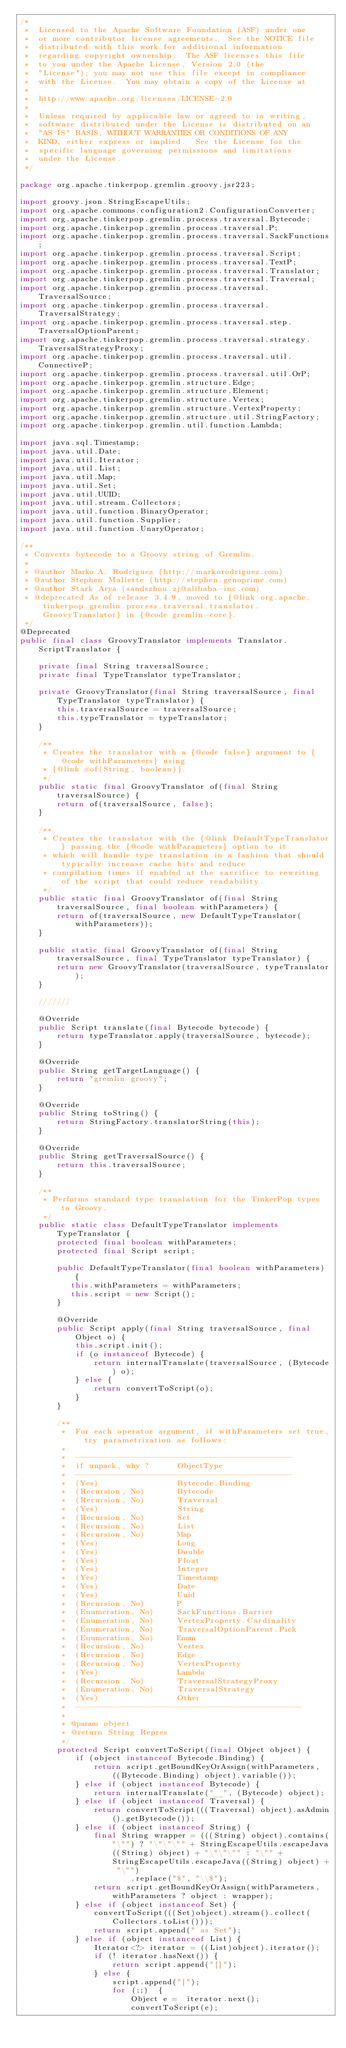Convert code to text. <code><loc_0><loc_0><loc_500><loc_500><_Java_>/*
 *  Licensed to the Apache Software Foundation (ASF) under one
 *  or more contributor license agreements.  See the NOTICE file
 *  distributed with this work for additional information
 *  regarding copyright ownership.  The ASF licenses this file
 *  to you under the Apache License, Version 2.0 (the
 *  "License"); you may not use this file except in compliance
 *  with the License.  You may obtain a copy of the License at
 *
 *  http://www.apache.org/licenses/LICENSE-2.0
 *
 *  Unless required by applicable law or agreed to in writing,
 *  software distributed under the License is distributed on an
 *  "AS IS" BASIS, WITHOUT WARRANTIES OR CONDITIONS OF ANY
 *  KIND, either express or implied.  See the License for the
 *  specific language governing permissions and limitations
 *  under the License.
 */

package org.apache.tinkerpop.gremlin.groovy.jsr223;

import groovy.json.StringEscapeUtils;
import org.apache.commons.configuration2.ConfigurationConverter;
import org.apache.tinkerpop.gremlin.process.traversal.Bytecode;
import org.apache.tinkerpop.gremlin.process.traversal.P;
import org.apache.tinkerpop.gremlin.process.traversal.SackFunctions;
import org.apache.tinkerpop.gremlin.process.traversal.Script;
import org.apache.tinkerpop.gremlin.process.traversal.TextP;
import org.apache.tinkerpop.gremlin.process.traversal.Translator;
import org.apache.tinkerpop.gremlin.process.traversal.Traversal;
import org.apache.tinkerpop.gremlin.process.traversal.TraversalSource;
import org.apache.tinkerpop.gremlin.process.traversal.TraversalStrategy;
import org.apache.tinkerpop.gremlin.process.traversal.step.TraversalOptionParent;
import org.apache.tinkerpop.gremlin.process.traversal.strategy.TraversalStrategyProxy;
import org.apache.tinkerpop.gremlin.process.traversal.util.ConnectiveP;
import org.apache.tinkerpop.gremlin.process.traversal.util.OrP;
import org.apache.tinkerpop.gremlin.structure.Edge;
import org.apache.tinkerpop.gremlin.structure.Element;
import org.apache.tinkerpop.gremlin.structure.Vertex;
import org.apache.tinkerpop.gremlin.structure.VertexProperty;
import org.apache.tinkerpop.gremlin.structure.util.StringFactory;
import org.apache.tinkerpop.gremlin.util.function.Lambda;

import java.sql.Timestamp;
import java.util.Date;
import java.util.Iterator;
import java.util.List;
import java.util.Map;
import java.util.Set;
import java.util.UUID;
import java.util.stream.Collectors;
import java.util.function.BinaryOperator;
import java.util.function.Supplier;
import java.util.function.UnaryOperator;

/**
 * Converts bytecode to a Groovy string of Gremlin.
 *
 * @author Marko A. Rodriguez (http://markorodriguez.com)
 * @author Stephen Mallette (http://stephen.genoprime.com)
 * @author Stark Arya (sandszhou.zj@alibaba-inc.com)
 * @deprecated As of release 3.4.9, moved to {@link org.apache.tinkerpop.gremlin.process.traversal.translator.GroovyTranslator} in {@code gremlin-core}.
 */
@Deprecated
public final class GroovyTranslator implements Translator.ScriptTranslator {

    private final String traversalSource;
    private final TypeTranslator typeTranslator;

    private GroovyTranslator(final String traversalSource, final TypeTranslator typeTranslator) {
        this.traversalSource = traversalSource;
        this.typeTranslator = typeTranslator;
    }

    /**
     * Creates the translator with a {@code false} argument to {@code withParameters} using
     * {@link #of(String, boolean)}.
     */
    public static final GroovyTranslator of(final String traversalSource) {
        return of(traversalSource, false);
    }

    /**
     * Creates the translator with the {@link DefaultTypeTranslator} passing the {@code withParameters} option to it
     * which will handle type translation in a fashion that should typically increase cache hits and reduce
     * compilation times if enabled at the sacrifice to rewriting of the script that could reduce readability.
     */
    public static final GroovyTranslator of(final String traversalSource, final boolean withParameters) {
        return of(traversalSource, new DefaultTypeTranslator(withParameters));
    }

    public static final GroovyTranslator of(final String traversalSource, final TypeTranslator typeTranslator) {
        return new GroovyTranslator(traversalSource, typeTranslator);
    }

    ///////

    @Override
    public Script translate(final Bytecode bytecode) {
        return typeTranslator.apply(traversalSource, bytecode);
    }

    @Override
    public String getTargetLanguage() {
        return "gremlin-groovy";
    }

    @Override
    public String toString() {
        return StringFactory.translatorString(this);
    }

    @Override
    public String getTraversalSource() {
        return this.traversalSource;
    }

    /**
     * Performs standard type translation for the TinkerPop types to Groovy.
     */
    public static class DefaultTypeTranslator implements TypeTranslator {
        protected final boolean withParameters;
        protected final Script script;

        public DefaultTypeTranslator(final boolean withParameters) {
           this.withParameters = withParameters;
           this.script = new Script();
        }

        @Override
        public Script apply(final String traversalSource, final Object o) {
            this.script.init();
            if (o instanceof Bytecode) {
                return internalTranslate(traversalSource, (Bytecode) o);
            } else {
                return convertToScript(o);
            }
        }

        /**
         *  For each operator argument, if withParameters set true, try parametrization as follows:
         *
         *  -----------------------------------------------
         *  if unpack, why ?      ObjectType
         *  -----------------------------------------------
         *  (Yes)                 Bytecode.Binding
         *  (Recursion, No)       Bytecode
         *  (Recursion, No)       Traversal
         *  (Yes)                 String
         *  (Recursion, No)       Set
         *  (Recursion, No)       List
         *  (Recursion, No)       Map
         *  (Yes)                 Long
         *  (Yes)                 Double
         *  (Yes)                 Float
         *  (Yes)                 Integer
         *  (Yes)                 Timestamp
         *  (Yes)                 Date
         *  (Yes)                 Uuid
         *  (Recursion, No)       P
         *  (Enumeration, No)     SackFunctions.Barrier
         *  (Enumeration, No)     VertexProperty.Cardinality
         *  (Enumeration, No)     TraversalOptionParent.Pick
         *  (Enumeration, No)     Enum
         *  (Recursion, No)       Vertex
         *  (Recursion, No)       Edge
         *  (Recursion, No)       VertexProperty
         *  (Yes)                 Lambda
         *  (Recursion, No)       TraversalStrategyProxy
         *  (Enumeration, No)     TraversalStrategy
         *  (Yes)                 Other
         *  -------------------------------------------------
         *
         * @param object
         * @return String Repres
         */
        protected Script convertToScript(final Object object) {
            if (object instanceof Bytecode.Binding) {
                return script.getBoundKeyOrAssign(withParameters, ((Bytecode.Binding) object).variable());
            } else if (object instanceof Bytecode) {
                return internalTranslate("__", (Bytecode) object);
            } else if (object instanceof Traversal) {
                return convertToScript(((Traversal) object).asAdmin().getBytecode());
            } else if (object instanceof String) {
                final String wrapper = (((String) object).contains("\"") ? "\"\"\"" + StringEscapeUtils.escapeJava((String) object) + "\"\"\"" : "\"" + StringEscapeUtils.escapeJava((String) object) + "\"")
                        .replace("$", "\\$");
                return script.getBoundKeyOrAssign(withParameters, withParameters ? object : wrapper);
            } else if (object instanceof Set) {
                convertToScript(((Set)object).stream().collect(Collectors.toList()));
                return script.append(" as Set");
            } else if (object instanceof List) {
                Iterator<?> iterator = ((List)object).iterator();
                if (! iterator.hasNext()) {
                    return script.append("[]");
                } else {
                    script.append("[");
                    for (;;)  {
                        Object e =  iterator.next();
                        convertToScript(e);</code> 